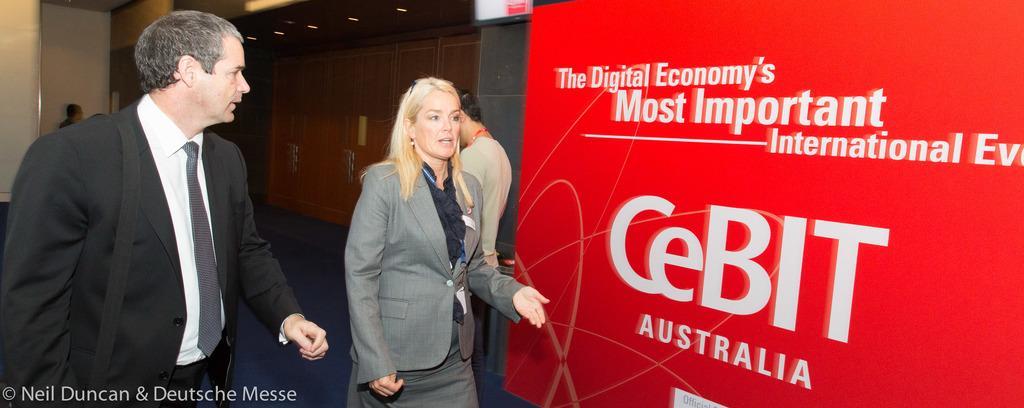Describe this image in one or two sentences. In this image I can see on the left side a man is there, he wore coat, tie, shirt, trouser. In the middle a woman is talking, she also wore coat. On the right side there is the board in red color. 